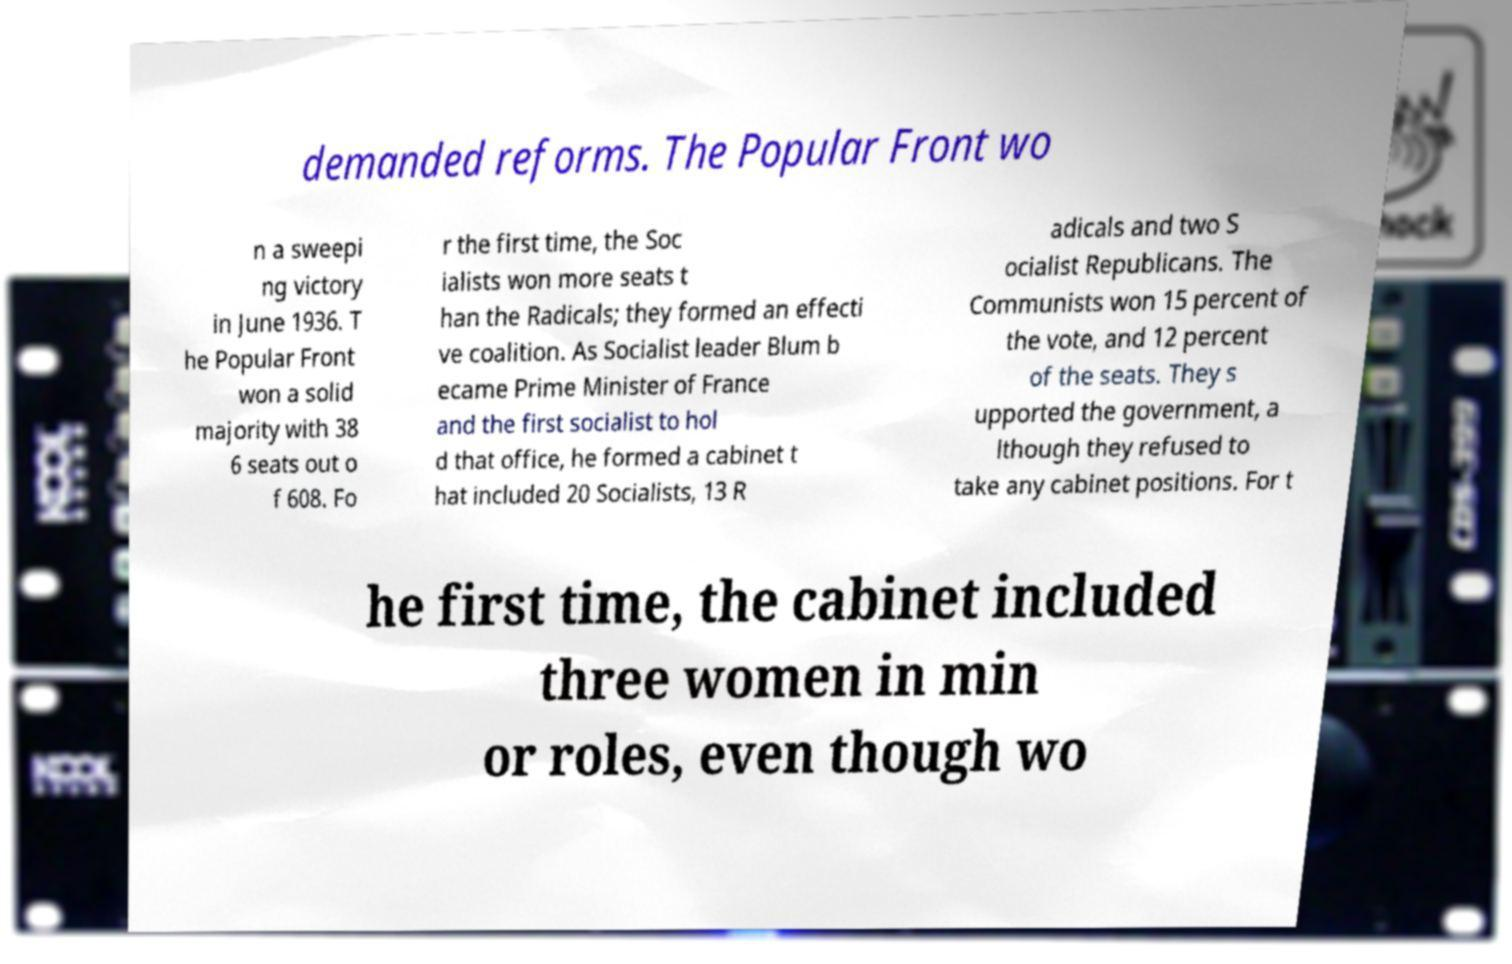Could you assist in decoding the text presented in this image and type it out clearly? demanded reforms. The Popular Front wo n a sweepi ng victory in June 1936. T he Popular Front won a solid majority with 38 6 seats out o f 608. Fo r the first time, the Soc ialists won more seats t han the Radicals; they formed an effecti ve coalition. As Socialist leader Blum b ecame Prime Minister of France and the first socialist to hol d that office, he formed a cabinet t hat included 20 Socialists, 13 R adicals and two S ocialist Republicans. The Communists won 15 percent of the vote, and 12 percent of the seats. They s upported the government, a lthough they refused to take any cabinet positions. For t he first time, the cabinet included three women in min or roles, even though wo 